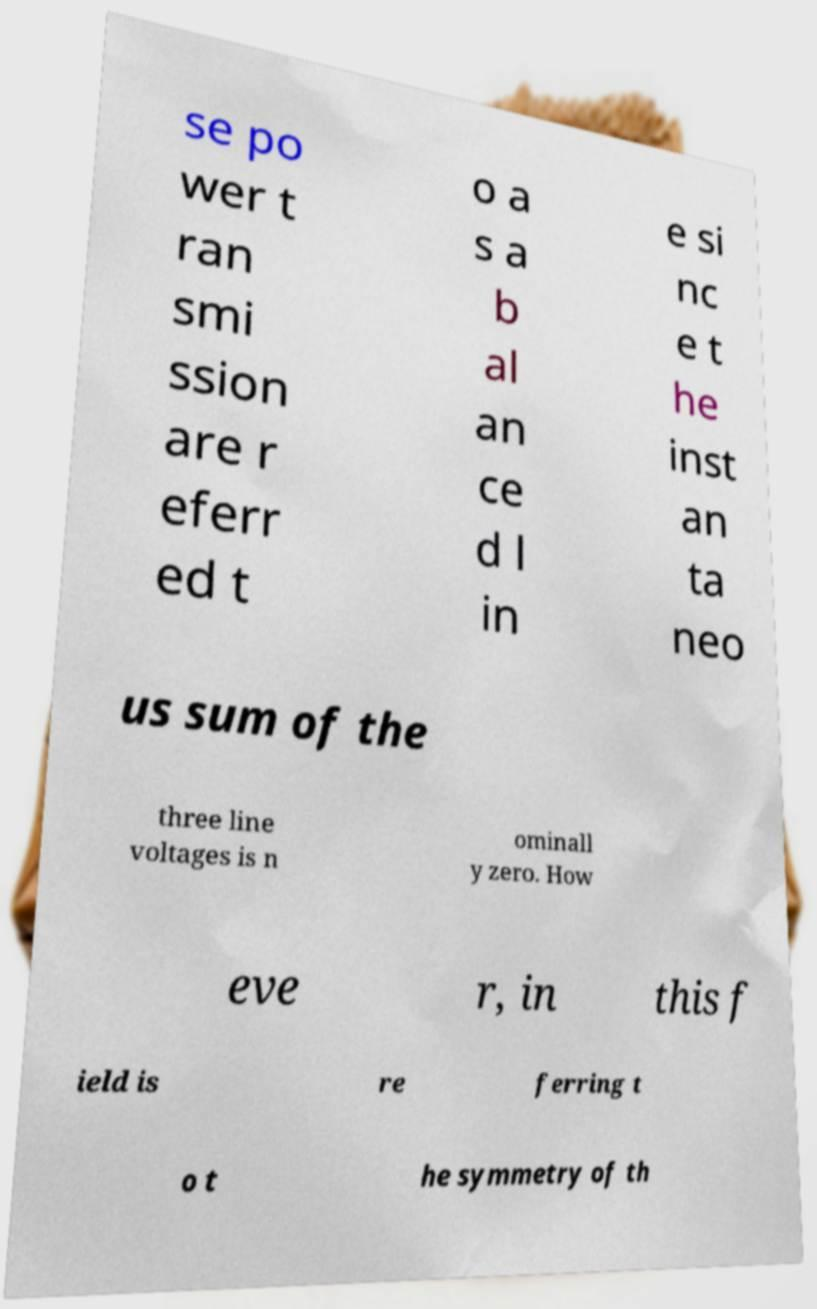Could you assist in decoding the text presented in this image and type it out clearly? se po wer t ran smi ssion are r eferr ed t o a s a b al an ce d l in e si nc e t he inst an ta neo us sum of the three line voltages is n ominall y zero. How eve r, in this f ield is re ferring t o t he symmetry of th 